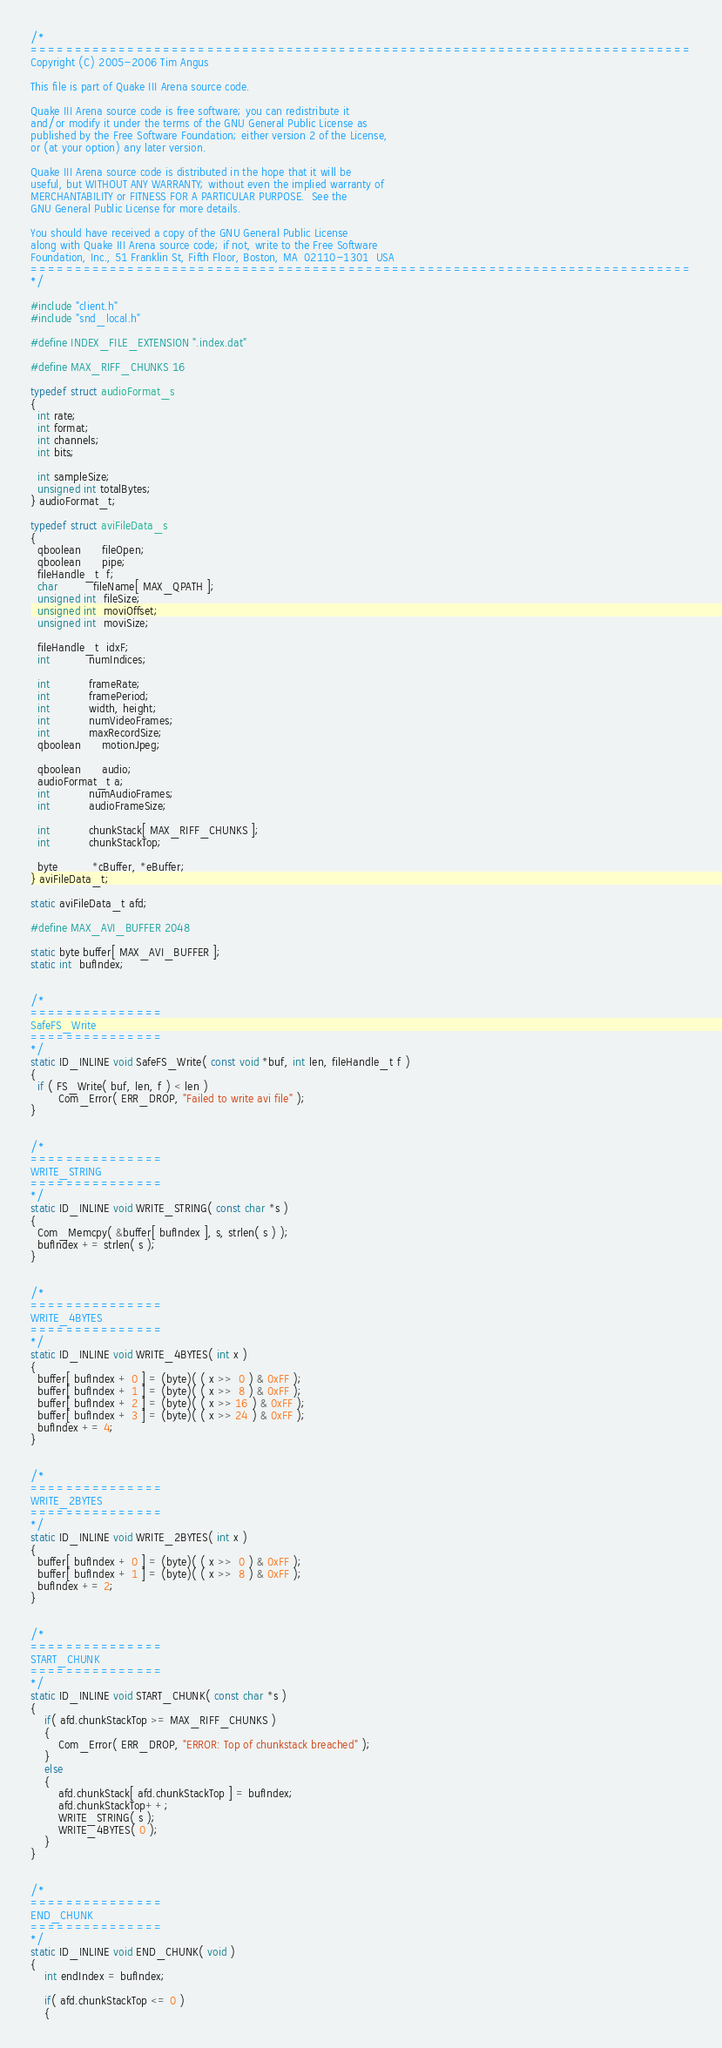Convert code to text. <code><loc_0><loc_0><loc_500><loc_500><_C_>/*
===========================================================================
Copyright (C) 2005-2006 Tim Angus

This file is part of Quake III Arena source code.

Quake III Arena source code is free software; you can redistribute it
and/or modify it under the terms of the GNU General Public License as
published by the Free Software Foundation; either version 2 of the License,
or (at your option) any later version.

Quake III Arena source code is distributed in the hope that it will be
useful, but WITHOUT ANY WARRANTY; without even the implied warranty of
MERCHANTABILITY or FITNESS FOR A PARTICULAR PURPOSE.  See the
GNU General Public License for more details.

You should have received a copy of the GNU General Public License
along with Quake III Arena source code; if not, write to the Free Software
Foundation, Inc., 51 Franklin St, Fifth Floor, Boston, MA  02110-1301  USA
===========================================================================
*/

#include "client.h"
#include "snd_local.h"

#define INDEX_FILE_EXTENSION ".index.dat"

#define MAX_RIFF_CHUNKS 16

typedef struct audioFormat_s
{
  int rate;
  int format;
  int channels;
  int bits;

  int sampleSize;
  unsigned int totalBytes;
} audioFormat_t;

typedef struct aviFileData_s
{
  qboolean      fileOpen;
  qboolean      pipe;
  fileHandle_t  f;
  char          fileName[ MAX_QPATH ];
  unsigned int  fileSize;
  unsigned int  moviOffset;
  unsigned int  moviSize;

  fileHandle_t  idxF;
  int           numIndices;

  int           frameRate;
  int           framePeriod;
  int           width, height;
  int           numVideoFrames;
  int           maxRecordSize;
  qboolean      motionJpeg;

  qboolean      audio;
  audioFormat_t a;
  int           numAudioFrames;
  int           audioFrameSize;

  int           chunkStack[ MAX_RIFF_CHUNKS ];
  int           chunkStackTop;

  byte          *cBuffer, *eBuffer;
} aviFileData_t;

static aviFileData_t afd;

#define MAX_AVI_BUFFER 2048

static byte buffer[ MAX_AVI_BUFFER ];
static int  bufIndex;


/*
===============
SafeFS_Write
===============
*/
static ID_INLINE void SafeFS_Write( const void *buf, int len, fileHandle_t f )
{
  if ( FS_Write( buf, len, f ) < len )
		Com_Error( ERR_DROP, "Failed to write avi file" );
}


/*
===============
WRITE_STRING
===============
*/
static ID_INLINE void WRITE_STRING( const char *s )
{
  Com_Memcpy( &buffer[ bufIndex ], s, strlen( s ) );
  bufIndex += strlen( s );
}


/*
===============
WRITE_4BYTES
===============
*/
static ID_INLINE void WRITE_4BYTES( int x )
{
  buffer[ bufIndex + 0 ] = (byte)( ( x >>  0 ) & 0xFF );
  buffer[ bufIndex + 1 ] = (byte)( ( x >>  8 ) & 0xFF );
  buffer[ bufIndex + 2 ] = (byte)( ( x >> 16 ) & 0xFF );
  buffer[ bufIndex + 3 ] = (byte)( ( x >> 24 ) & 0xFF );
  bufIndex += 4;
}


/*
===============
WRITE_2BYTES
===============
*/
static ID_INLINE void WRITE_2BYTES( int x )
{
  buffer[ bufIndex + 0 ] = (byte)( ( x >>  0 ) & 0xFF );
  buffer[ bufIndex + 1 ] = (byte)( ( x >>  8 ) & 0xFF );
  bufIndex += 2;
}


/*
===============
START_CHUNK
===============
*/
static ID_INLINE void START_CHUNK( const char *s )
{
	if( afd.chunkStackTop >= MAX_RIFF_CHUNKS )
	{
		Com_Error( ERR_DROP, "ERROR: Top of chunkstack breached" );
	} 
	else 
	{
		afd.chunkStack[ afd.chunkStackTop ] = bufIndex;
		afd.chunkStackTop++;
		WRITE_STRING( s );
		WRITE_4BYTES( 0 );
	}
}


/*
===============
END_CHUNK
===============
*/
static ID_INLINE void END_CHUNK( void )
{
	int endIndex = bufIndex;

	if( afd.chunkStackTop <= 0 )
	{</code> 